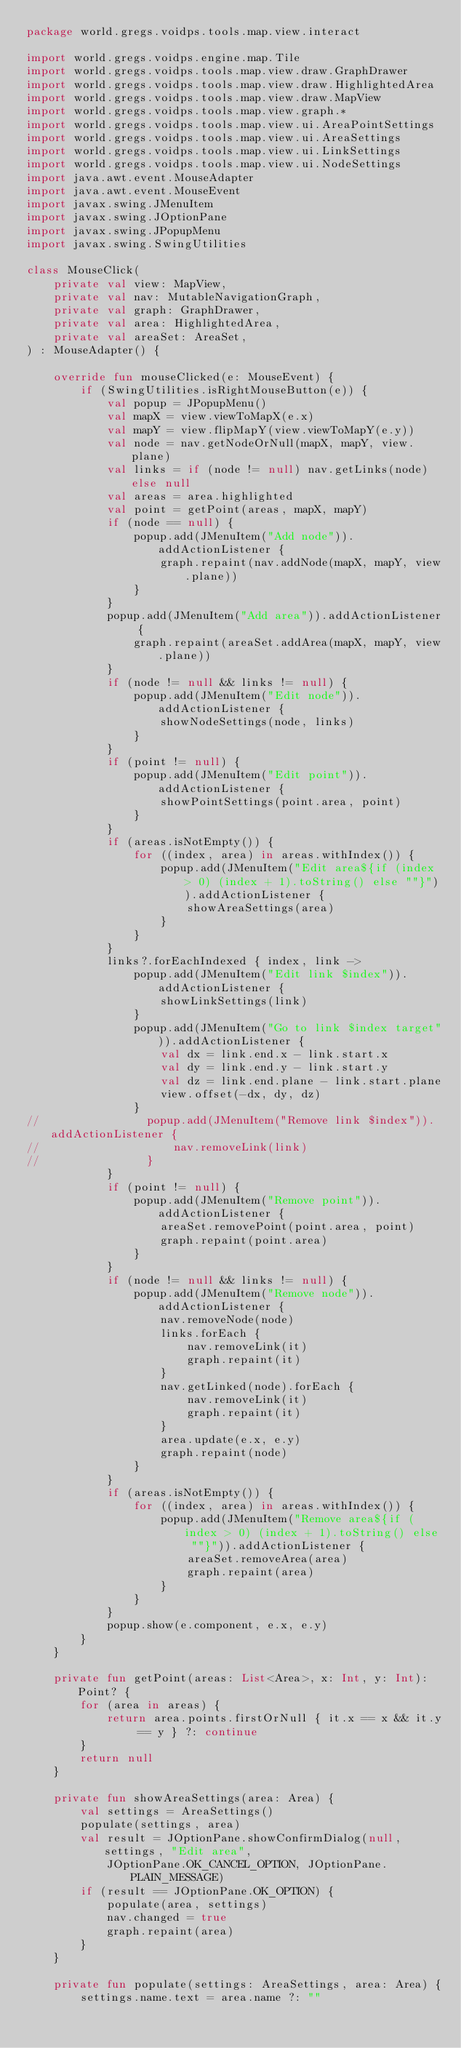<code> <loc_0><loc_0><loc_500><loc_500><_Kotlin_>package world.gregs.voidps.tools.map.view.interact

import world.gregs.voidps.engine.map.Tile
import world.gregs.voidps.tools.map.view.draw.GraphDrawer
import world.gregs.voidps.tools.map.view.draw.HighlightedArea
import world.gregs.voidps.tools.map.view.draw.MapView
import world.gregs.voidps.tools.map.view.graph.*
import world.gregs.voidps.tools.map.view.ui.AreaPointSettings
import world.gregs.voidps.tools.map.view.ui.AreaSettings
import world.gregs.voidps.tools.map.view.ui.LinkSettings
import world.gregs.voidps.tools.map.view.ui.NodeSettings
import java.awt.event.MouseAdapter
import java.awt.event.MouseEvent
import javax.swing.JMenuItem
import javax.swing.JOptionPane
import javax.swing.JPopupMenu
import javax.swing.SwingUtilities

class MouseClick(
    private val view: MapView,
    private val nav: MutableNavigationGraph,
    private val graph: GraphDrawer,
    private val area: HighlightedArea,
    private val areaSet: AreaSet,
) : MouseAdapter() {

    override fun mouseClicked(e: MouseEvent) {
        if (SwingUtilities.isRightMouseButton(e)) {
            val popup = JPopupMenu()
            val mapX = view.viewToMapX(e.x)
            val mapY = view.flipMapY(view.viewToMapY(e.y))
            val node = nav.getNodeOrNull(mapX, mapY, view.plane)
            val links = if (node != null) nav.getLinks(node) else null
            val areas = area.highlighted
            val point = getPoint(areas, mapX, mapY)
            if (node == null) {
                popup.add(JMenuItem("Add node")).addActionListener {
                    graph.repaint(nav.addNode(mapX, mapY, view.plane))
                }
            }
            popup.add(JMenuItem("Add area")).addActionListener {
                graph.repaint(areaSet.addArea(mapX, mapY, view.plane))
            }
            if (node != null && links != null) {
                popup.add(JMenuItem("Edit node")).addActionListener {
                    showNodeSettings(node, links)
                }
            }
            if (point != null) {
                popup.add(JMenuItem("Edit point")).addActionListener {
                    showPointSettings(point.area, point)
                }
            }
            if (areas.isNotEmpty()) {
                for ((index, area) in areas.withIndex()) {
                    popup.add(JMenuItem("Edit area${if (index > 0) (index + 1).toString() else ""}")).addActionListener {
                        showAreaSettings(area)
                    }
                }
            }
            links?.forEachIndexed { index, link ->
                popup.add(JMenuItem("Edit link $index")).addActionListener {
                    showLinkSettings(link)
                }
                popup.add(JMenuItem("Go to link $index target")).addActionListener {
                    val dx = link.end.x - link.start.x
                    val dy = link.end.y - link.start.y
                    val dz = link.end.plane - link.start.plane
                    view.offset(-dx, dy, dz)
                }
//                popup.add(JMenuItem("Remove link $index")).addActionListener {
//                    nav.removeLink(link)
//                }
            }
            if (point != null) {
                popup.add(JMenuItem("Remove point")).addActionListener {
                    areaSet.removePoint(point.area, point)
                    graph.repaint(point.area)
                }
            }
            if (node != null && links != null) {
                popup.add(JMenuItem("Remove node")).addActionListener {
                    nav.removeNode(node)
                    links.forEach {
                        nav.removeLink(it)
                        graph.repaint(it)
                    }
                    nav.getLinked(node).forEach {
                        nav.removeLink(it)
                        graph.repaint(it)
                    }
                    area.update(e.x, e.y)
                    graph.repaint(node)
                }
            }
            if (areas.isNotEmpty()) {
                for ((index, area) in areas.withIndex()) {
                    popup.add(JMenuItem("Remove area${if (index > 0) (index + 1).toString() else ""}")).addActionListener {
                        areaSet.removeArea(area)
                        graph.repaint(area)
                    }
                }
            }
            popup.show(e.component, e.x, e.y)
        }
    }

    private fun getPoint(areas: List<Area>, x: Int, y: Int): Point? {
        for (area in areas) {
            return area.points.firstOrNull { it.x == x && it.y == y } ?: continue
        }
        return null
    }

    private fun showAreaSettings(area: Area) {
        val settings = AreaSettings()
        populate(settings, area)
        val result = JOptionPane.showConfirmDialog(null, settings, "Edit area",
            JOptionPane.OK_CANCEL_OPTION, JOptionPane.PLAIN_MESSAGE)
        if (result == JOptionPane.OK_OPTION) {
            populate(area, settings)
            nav.changed = true
            graph.repaint(area)
        }
    }

    private fun populate(settings: AreaSettings, area: Area) {
        settings.name.text = area.name ?: ""</code> 